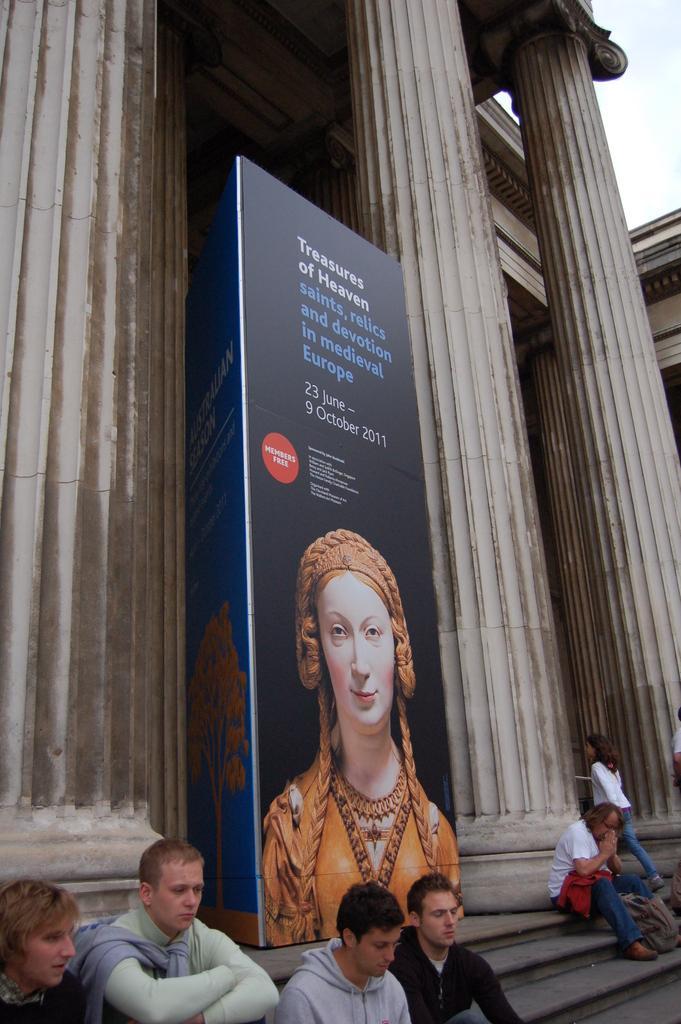In one or two sentences, can you explain what this image depicts? There are steps. On that some people are sitting. In the back there are pillars. Near to that there is a banner. On that something is written and there is a picture of a lady. 